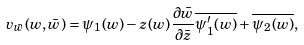<formula> <loc_0><loc_0><loc_500><loc_500>v _ { \bar { w } } ( w , \bar { w } ) = \psi _ { 1 } ( w ) - z ( w ) \frac { \partial \bar { w } } { \partial \bar { z } } \overline { \psi ^ { \prime } _ { 1 } ( w ) } + \overline { \psi _ { 2 } ( w ) } ,</formula> 